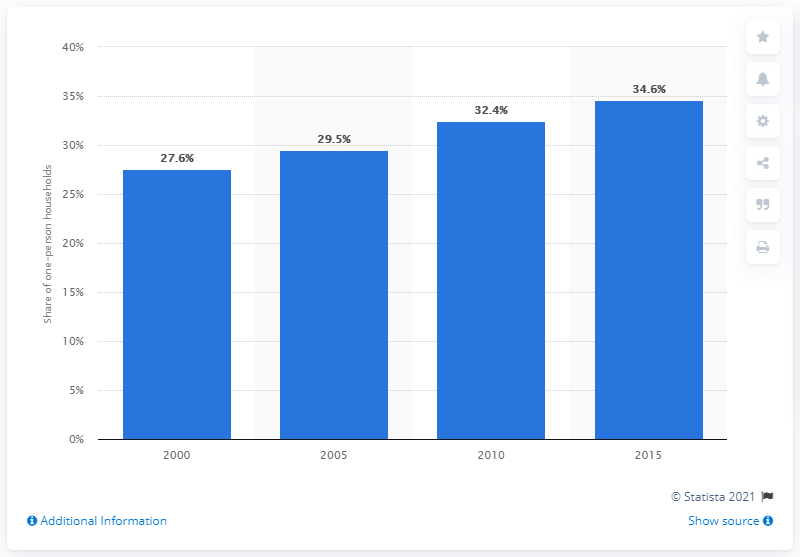List a handful of essential elements in this visual. In 2015, approximately 34.6% of private households in Japan were one-person households. 